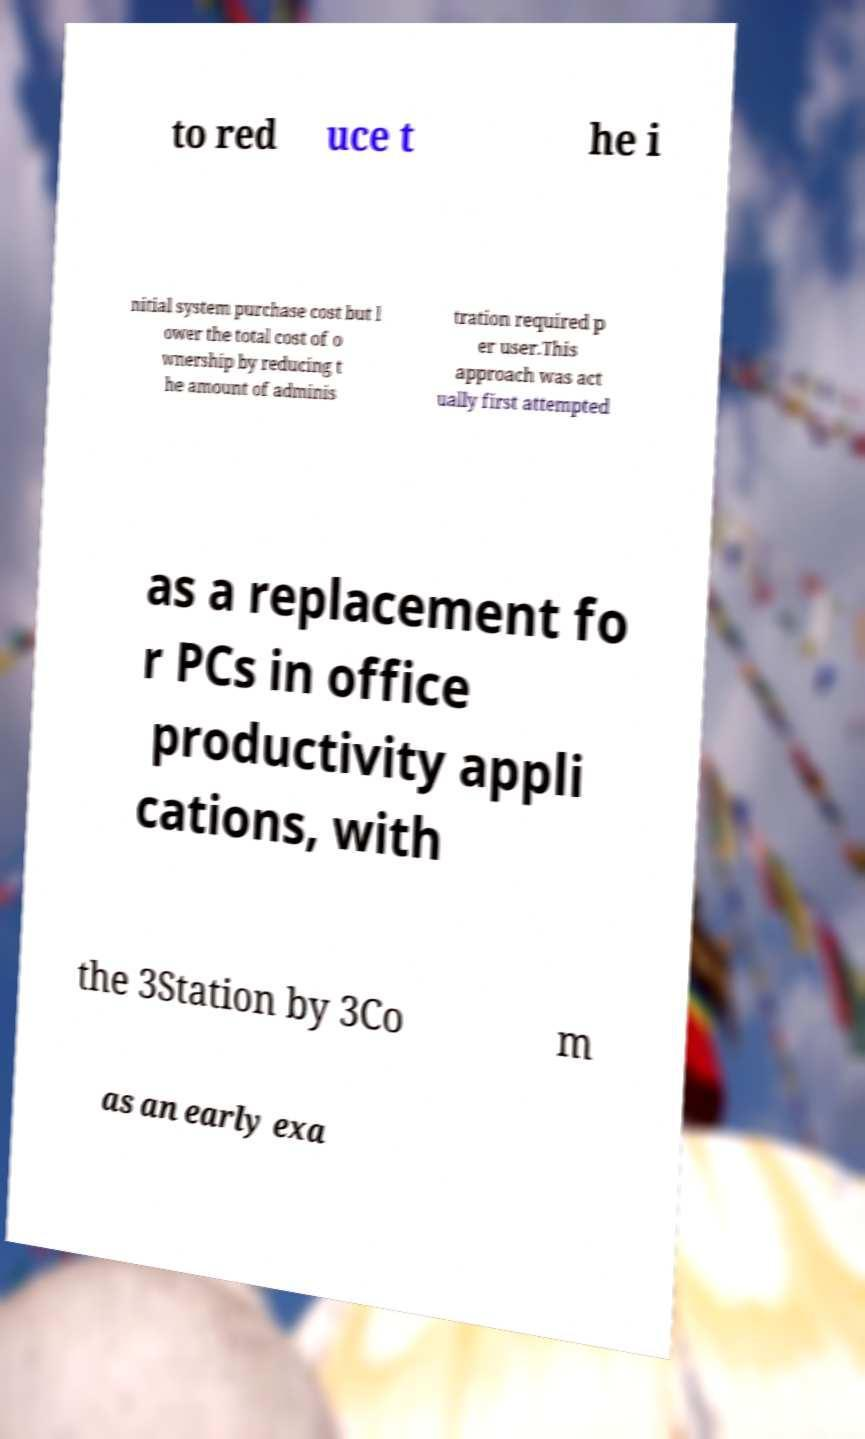What messages or text are displayed in this image? I need them in a readable, typed format. to red uce t he i nitial system purchase cost but l ower the total cost of o wnership by reducing t he amount of adminis tration required p er user.This approach was act ually first attempted as a replacement fo r PCs in office productivity appli cations, with the 3Station by 3Co m as an early exa 